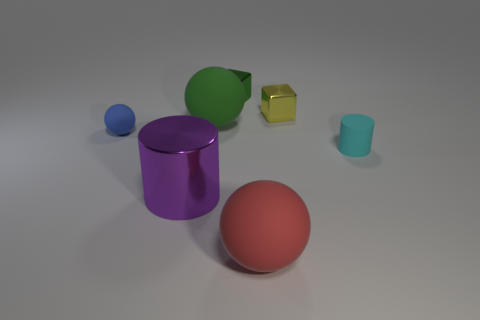There is a large thing that is behind the tiny cyan matte object; is it the same shape as the big object that is on the right side of the green shiny block?
Offer a very short reply. Yes. Are there any tiny blue rubber spheres?
Ensure brevity in your answer.  Yes. The small rubber object that is the same shape as the purple shiny object is what color?
Give a very brief answer. Cyan. What color is the other ball that is the same size as the red sphere?
Your answer should be very brief. Green. Do the big purple object and the cyan object have the same material?
Give a very brief answer. No. How many matte spheres have the same color as the shiny cylinder?
Offer a terse response. 0. Is the color of the big metal thing the same as the tiny matte ball?
Provide a short and direct response. No. There is a block that is left of the red thing; what is it made of?
Give a very brief answer. Metal. What number of tiny things are either cyan matte things or gray metal blocks?
Your response must be concise. 1. Is there a large purple cylinder made of the same material as the small blue sphere?
Offer a terse response. No. 